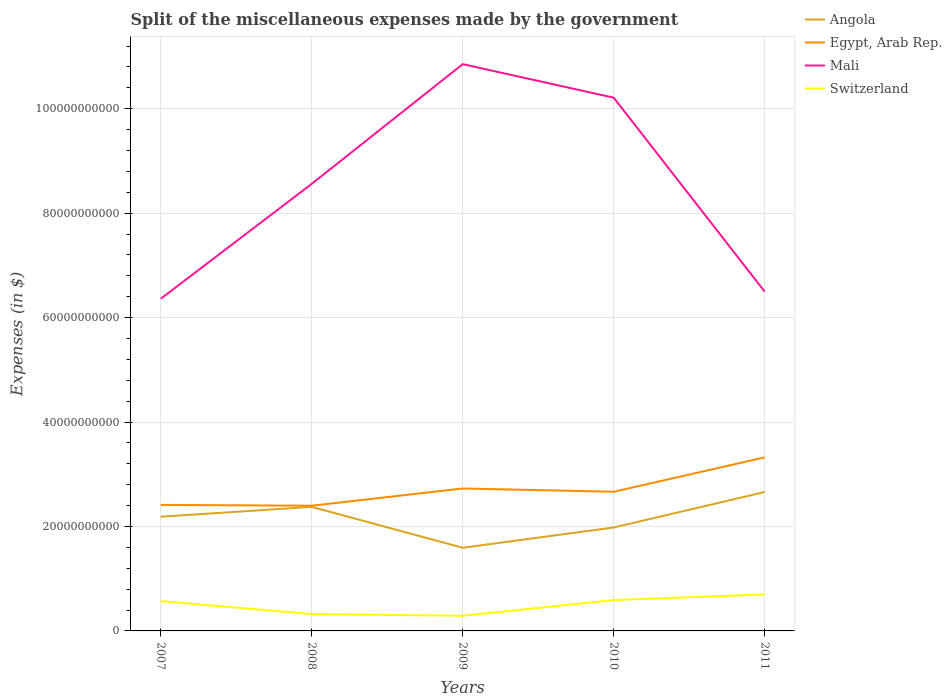How many different coloured lines are there?
Make the answer very short. 4. Does the line corresponding to Egypt, Arab Rep. intersect with the line corresponding to Angola?
Ensure brevity in your answer.  No. Across all years, what is the maximum miscellaneous expenses made by the government in Switzerland?
Provide a short and direct response. 2.91e+09. In which year was the miscellaneous expenses made by the government in Switzerland maximum?
Keep it short and to the point. 2009. What is the total miscellaneous expenses made by the government in Angola in the graph?
Offer a terse response. -6.79e+09. What is the difference between the highest and the second highest miscellaneous expenses made by the government in Angola?
Give a very brief answer. 1.07e+1. How many years are there in the graph?
Ensure brevity in your answer.  5. Where does the legend appear in the graph?
Offer a very short reply. Top right. How are the legend labels stacked?
Give a very brief answer. Vertical. What is the title of the graph?
Your answer should be very brief. Split of the miscellaneous expenses made by the government. Does "Indonesia" appear as one of the legend labels in the graph?
Your answer should be very brief. No. What is the label or title of the Y-axis?
Your answer should be compact. Expenses (in $). What is the Expenses (in $) in Angola in 2007?
Offer a terse response. 2.19e+1. What is the Expenses (in $) in Egypt, Arab Rep. in 2007?
Give a very brief answer. 2.41e+1. What is the Expenses (in $) of Mali in 2007?
Make the answer very short. 6.36e+1. What is the Expenses (in $) of Switzerland in 2007?
Provide a succinct answer. 5.72e+09. What is the Expenses (in $) of Angola in 2008?
Make the answer very short. 2.38e+1. What is the Expenses (in $) of Egypt, Arab Rep. in 2008?
Provide a short and direct response. 2.40e+1. What is the Expenses (in $) in Mali in 2008?
Ensure brevity in your answer.  8.56e+1. What is the Expenses (in $) of Switzerland in 2008?
Offer a terse response. 3.22e+09. What is the Expenses (in $) of Angola in 2009?
Ensure brevity in your answer.  1.59e+1. What is the Expenses (in $) in Egypt, Arab Rep. in 2009?
Give a very brief answer. 2.73e+1. What is the Expenses (in $) of Mali in 2009?
Your answer should be compact. 1.09e+11. What is the Expenses (in $) of Switzerland in 2009?
Offer a very short reply. 2.91e+09. What is the Expenses (in $) of Angola in 2010?
Ensure brevity in your answer.  1.98e+1. What is the Expenses (in $) of Egypt, Arab Rep. in 2010?
Keep it short and to the point. 2.66e+1. What is the Expenses (in $) of Mali in 2010?
Offer a very short reply. 1.02e+11. What is the Expenses (in $) of Switzerland in 2010?
Provide a short and direct response. 5.91e+09. What is the Expenses (in $) in Angola in 2011?
Give a very brief answer. 2.66e+1. What is the Expenses (in $) in Egypt, Arab Rep. in 2011?
Keep it short and to the point. 3.32e+1. What is the Expenses (in $) of Mali in 2011?
Provide a short and direct response. 6.50e+1. What is the Expenses (in $) in Switzerland in 2011?
Provide a short and direct response. 6.99e+09. Across all years, what is the maximum Expenses (in $) of Angola?
Make the answer very short. 2.66e+1. Across all years, what is the maximum Expenses (in $) in Egypt, Arab Rep.?
Give a very brief answer. 3.32e+1. Across all years, what is the maximum Expenses (in $) in Mali?
Make the answer very short. 1.09e+11. Across all years, what is the maximum Expenses (in $) in Switzerland?
Provide a succinct answer. 6.99e+09. Across all years, what is the minimum Expenses (in $) in Angola?
Your answer should be compact. 1.59e+1. Across all years, what is the minimum Expenses (in $) of Egypt, Arab Rep.?
Give a very brief answer. 2.40e+1. Across all years, what is the minimum Expenses (in $) in Mali?
Provide a succinct answer. 6.36e+1. Across all years, what is the minimum Expenses (in $) in Switzerland?
Keep it short and to the point. 2.91e+09. What is the total Expenses (in $) in Angola in the graph?
Offer a terse response. 1.08e+11. What is the total Expenses (in $) of Egypt, Arab Rep. in the graph?
Provide a short and direct response. 1.35e+11. What is the total Expenses (in $) of Mali in the graph?
Provide a short and direct response. 4.25e+11. What is the total Expenses (in $) of Switzerland in the graph?
Make the answer very short. 2.47e+1. What is the difference between the Expenses (in $) in Angola in 2007 and that in 2008?
Your answer should be very brief. -1.88e+09. What is the difference between the Expenses (in $) in Egypt, Arab Rep. in 2007 and that in 2008?
Offer a very short reply. 1.59e+08. What is the difference between the Expenses (in $) of Mali in 2007 and that in 2008?
Offer a very short reply. -2.20e+1. What is the difference between the Expenses (in $) in Switzerland in 2007 and that in 2008?
Offer a terse response. 2.49e+09. What is the difference between the Expenses (in $) in Angola in 2007 and that in 2009?
Give a very brief answer. 5.95e+09. What is the difference between the Expenses (in $) in Egypt, Arab Rep. in 2007 and that in 2009?
Make the answer very short. -3.14e+09. What is the difference between the Expenses (in $) in Mali in 2007 and that in 2009?
Make the answer very short. -4.49e+1. What is the difference between the Expenses (in $) in Switzerland in 2007 and that in 2009?
Provide a succinct answer. 2.81e+09. What is the difference between the Expenses (in $) of Angola in 2007 and that in 2010?
Give a very brief answer. 2.07e+09. What is the difference between the Expenses (in $) in Egypt, Arab Rep. in 2007 and that in 2010?
Your response must be concise. -2.52e+09. What is the difference between the Expenses (in $) of Mali in 2007 and that in 2010?
Your answer should be compact. -3.85e+1. What is the difference between the Expenses (in $) of Switzerland in 2007 and that in 2010?
Provide a succinct answer. -1.89e+08. What is the difference between the Expenses (in $) of Angola in 2007 and that in 2011?
Keep it short and to the point. -4.73e+09. What is the difference between the Expenses (in $) of Egypt, Arab Rep. in 2007 and that in 2011?
Offer a terse response. -9.10e+09. What is the difference between the Expenses (in $) in Mali in 2007 and that in 2011?
Give a very brief answer. -1.37e+09. What is the difference between the Expenses (in $) in Switzerland in 2007 and that in 2011?
Keep it short and to the point. -1.28e+09. What is the difference between the Expenses (in $) in Angola in 2008 and that in 2009?
Ensure brevity in your answer.  7.83e+09. What is the difference between the Expenses (in $) in Egypt, Arab Rep. in 2008 and that in 2009?
Ensure brevity in your answer.  -3.30e+09. What is the difference between the Expenses (in $) in Mali in 2008 and that in 2009?
Provide a short and direct response. -2.29e+1. What is the difference between the Expenses (in $) in Switzerland in 2008 and that in 2009?
Keep it short and to the point. 3.19e+08. What is the difference between the Expenses (in $) in Angola in 2008 and that in 2010?
Your answer should be very brief. 3.95e+09. What is the difference between the Expenses (in $) in Egypt, Arab Rep. in 2008 and that in 2010?
Your answer should be compact. -2.67e+09. What is the difference between the Expenses (in $) of Mali in 2008 and that in 2010?
Your answer should be very brief. -1.65e+1. What is the difference between the Expenses (in $) of Switzerland in 2008 and that in 2010?
Keep it short and to the point. -2.68e+09. What is the difference between the Expenses (in $) of Angola in 2008 and that in 2011?
Make the answer very short. -2.84e+09. What is the difference between the Expenses (in $) in Egypt, Arab Rep. in 2008 and that in 2011?
Give a very brief answer. -9.26e+09. What is the difference between the Expenses (in $) of Mali in 2008 and that in 2011?
Ensure brevity in your answer.  2.06e+1. What is the difference between the Expenses (in $) of Switzerland in 2008 and that in 2011?
Keep it short and to the point. -3.77e+09. What is the difference between the Expenses (in $) in Angola in 2009 and that in 2010?
Provide a short and direct response. -3.88e+09. What is the difference between the Expenses (in $) of Egypt, Arab Rep. in 2009 and that in 2010?
Give a very brief answer. 6.29e+08. What is the difference between the Expenses (in $) of Mali in 2009 and that in 2010?
Offer a terse response. 6.42e+09. What is the difference between the Expenses (in $) in Switzerland in 2009 and that in 2010?
Offer a very short reply. -3.00e+09. What is the difference between the Expenses (in $) of Angola in 2009 and that in 2011?
Provide a short and direct response. -1.07e+1. What is the difference between the Expenses (in $) of Egypt, Arab Rep. in 2009 and that in 2011?
Your answer should be very brief. -5.96e+09. What is the difference between the Expenses (in $) of Mali in 2009 and that in 2011?
Offer a very short reply. 4.36e+1. What is the difference between the Expenses (in $) of Switzerland in 2009 and that in 2011?
Your answer should be very brief. -4.09e+09. What is the difference between the Expenses (in $) of Angola in 2010 and that in 2011?
Keep it short and to the point. -6.79e+09. What is the difference between the Expenses (in $) of Egypt, Arab Rep. in 2010 and that in 2011?
Provide a succinct answer. -6.59e+09. What is the difference between the Expenses (in $) in Mali in 2010 and that in 2011?
Provide a short and direct response. 3.71e+1. What is the difference between the Expenses (in $) of Switzerland in 2010 and that in 2011?
Your response must be concise. -1.09e+09. What is the difference between the Expenses (in $) in Angola in 2007 and the Expenses (in $) in Egypt, Arab Rep. in 2008?
Offer a terse response. -2.10e+09. What is the difference between the Expenses (in $) of Angola in 2007 and the Expenses (in $) of Mali in 2008?
Make the answer very short. -6.37e+1. What is the difference between the Expenses (in $) of Angola in 2007 and the Expenses (in $) of Switzerland in 2008?
Keep it short and to the point. 1.86e+1. What is the difference between the Expenses (in $) of Egypt, Arab Rep. in 2007 and the Expenses (in $) of Mali in 2008?
Ensure brevity in your answer.  -6.15e+1. What is the difference between the Expenses (in $) of Egypt, Arab Rep. in 2007 and the Expenses (in $) of Switzerland in 2008?
Ensure brevity in your answer.  2.09e+1. What is the difference between the Expenses (in $) of Mali in 2007 and the Expenses (in $) of Switzerland in 2008?
Keep it short and to the point. 6.04e+1. What is the difference between the Expenses (in $) in Angola in 2007 and the Expenses (in $) in Egypt, Arab Rep. in 2009?
Offer a terse response. -5.41e+09. What is the difference between the Expenses (in $) of Angola in 2007 and the Expenses (in $) of Mali in 2009?
Make the answer very short. -8.67e+1. What is the difference between the Expenses (in $) in Angola in 2007 and the Expenses (in $) in Switzerland in 2009?
Your response must be concise. 1.90e+1. What is the difference between the Expenses (in $) of Egypt, Arab Rep. in 2007 and the Expenses (in $) of Mali in 2009?
Keep it short and to the point. -8.44e+1. What is the difference between the Expenses (in $) of Egypt, Arab Rep. in 2007 and the Expenses (in $) of Switzerland in 2009?
Your answer should be compact. 2.12e+1. What is the difference between the Expenses (in $) in Mali in 2007 and the Expenses (in $) in Switzerland in 2009?
Keep it short and to the point. 6.07e+1. What is the difference between the Expenses (in $) in Angola in 2007 and the Expenses (in $) in Egypt, Arab Rep. in 2010?
Keep it short and to the point. -4.78e+09. What is the difference between the Expenses (in $) in Angola in 2007 and the Expenses (in $) in Mali in 2010?
Make the answer very short. -8.02e+1. What is the difference between the Expenses (in $) in Angola in 2007 and the Expenses (in $) in Switzerland in 2010?
Offer a very short reply. 1.60e+1. What is the difference between the Expenses (in $) of Egypt, Arab Rep. in 2007 and the Expenses (in $) of Mali in 2010?
Keep it short and to the point. -7.80e+1. What is the difference between the Expenses (in $) in Egypt, Arab Rep. in 2007 and the Expenses (in $) in Switzerland in 2010?
Give a very brief answer. 1.82e+1. What is the difference between the Expenses (in $) in Mali in 2007 and the Expenses (in $) in Switzerland in 2010?
Make the answer very short. 5.77e+1. What is the difference between the Expenses (in $) of Angola in 2007 and the Expenses (in $) of Egypt, Arab Rep. in 2011?
Your answer should be very brief. -1.14e+1. What is the difference between the Expenses (in $) of Angola in 2007 and the Expenses (in $) of Mali in 2011?
Provide a succinct answer. -4.31e+1. What is the difference between the Expenses (in $) in Angola in 2007 and the Expenses (in $) in Switzerland in 2011?
Provide a short and direct response. 1.49e+1. What is the difference between the Expenses (in $) in Egypt, Arab Rep. in 2007 and the Expenses (in $) in Mali in 2011?
Your response must be concise. -4.08e+1. What is the difference between the Expenses (in $) in Egypt, Arab Rep. in 2007 and the Expenses (in $) in Switzerland in 2011?
Your answer should be compact. 1.71e+1. What is the difference between the Expenses (in $) in Mali in 2007 and the Expenses (in $) in Switzerland in 2011?
Your answer should be very brief. 5.66e+1. What is the difference between the Expenses (in $) in Angola in 2008 and the Expenses (in $) in Egypt, Arab Rep. in 2009?
Offer a terse response. -3.52e+09. What is the difference between the Expenses (in $) in Angola in 2008 and the Expenses (in $) in Mali in 2009?
Make the answer very short. -8.48e+1. What is the difference between the Expenses (in $) of Angola in 2008 and the Expenses (in $) of Switzerland in 2009?
Offer a very short reply. 2.08e+1. What is the difference between the Expenses (in $) in Egypt, Arab Rep. in 2008 and the Expenses (in $) in Mali in 2009?
Your response must be concise. -8.46e+1. What is the difference between the Expenses (in $) of Egypt, Arab Rep. in 2008 and the Expenses (in $) of Switzerland in 2009?
Your answer should be compact. 2.11e+1. What is the difference between the Expenses (in $) in Mali in 2008 and the Expenses (in $) in Switzerland in 2009?
Make the answer very short. 8.27e+1. What is the difference between the Expenses (in $) of Angola in 2008 and the Expenses (in $) of Egypt, Arab Rep. in 2010?
Offer a very short reply. -2.89e+09. What is the difference between the Expenses (in $) in Angola in 2008 and the Expenses (in $) in Mali in 2010?
Offer a very short reply. -7.84e+1. What is the difference between the Expenses (in $) of Angola in 2008 and the Expenses (in $) of Switzerland in 2010?
Make the answer very short. 1.78e+1. What is the difference between the Expenses (in $) of Egypt, Arab Rep. in 2008 and the Expenses (in $) of Mali in 2010?
Provide a short and direct response. -7.81e+1. What is the difference between the Expenses (in $) of Egypt, Arab Rep. in 2008 and the Expenses (in $) of Switzerland in 2010?
Offer a terse response. 1.81e+1. What is the difference between the Expenses (in $) in Mali in 2008 and the Expenses (in $) in Switzerland in 2010?
Your answer should be very brief. 7.97e+1. What is the difference between the Expenses (in $) of Angola in 2008 and the Expenses (in $) of Egypt, Arab Rep. in 2011?
Provide a succinct answer. -9.48e+09. What is the difference between the Expenses (in $) of Angola in 2008 and the Expenses (in $) of Mali in 2011?
Keep it short and to the point. -4.12e+1. What is the difference between the Expenses (in $) of Angola in 2008 and the Expenses (in $) of Switzerland in 2011?
Your answer should be very brief. 1.68e+1. What is the difference between the Expenses (in $) in Egypt, Arab Rep. in 2008 and the Expenses (in $) in Mali in 2011?
Offer a very short reply. -4.10e+1. What is the difference between the Expenses (in $) of Egypt, Arab Rep. in 2008 and the Expenses (in $) of Switzerland in 2011?
Give a very brief answer. 1.70e+1. What is the difference between the Expenses (in $) of Mali in 2008 and the Expenses (in $) of Switzerland in 2011?
Keep it short and to the point. 7.86e+1. What is the difference between the Expenses (in $) in Angola in 2009 and the Expenses (in $) in Egypt, Arab Rep. in 2010?
Ensure brevity in your answer.  -1.07e+1. What is the difference between the Expenses (in $) of Angola in 2009 and the Expenses (in $) of Mali in 2010?
Give a very brief answer. -8.62e+1. What is the difference between the Expenses (in $) in Angola in 2009 and the Expenses (in $) in Switzerland in 2010?
Make the answer very short. 1.00e+1. What is the difference between the Expenses (in $) in Egypt, Arab Rep. in 2009 and the Expenses (in $) in Mali in 2010?
Make the answer very short. -7.48e+1. What is the difference between the Expenses (in $) of Egypt, Arab Rep. in 2009 and the Expenses (in $) of Switzerland in 2010?
Provide a short and direct response. 2.14e+1. What is the difference between the Expenses (in $) of Mali in 2009 and the Expenses (in $) of Switzerland in 2010?
Offer a terse response. 1.03e+11. What is the difference between the Expenses (in $) of Angola in 2009 and the Expenses (in $) of Egypt, Arab Rep. in 2011?
Your answer should be very brief. -1.73e+1. What is the difference between the Expenses (in $) of Angola in 2009 and the Expenses (in $) of Mali in 2011?
Make the answer very short. -4.90e+1. What is the difference between the Expenses (in $) in Angola in 2009 and the Expenses (in $) in Switzerland in 2011?
Keep it short and to the point. 8.93e+09. What is the difference between the Expenses (in $) of Egypt, Arab Rep. in 2009 and the Expenses (in $) of Mali in 2011?
Your answer should be very brief. -3.77e+1. What is the difference between the Expenses (in $) of Egypt, Arab Rep. in 2009 and the Expenses (in $) of Switzerland in 2011?
Make the answer very short. 2.03e+1. What is the difference between the Expenses (in $) in Mali in 2009 and the Expenses (in $) in Switzerland in 2011?
Offer a very short reply. 1.02e+11. What is the difference between the Expenses (in $) of Angola in 2010 and the Expenses (in $) of Egypt, Arab Rep. in 2011?
Provide a succinct answer. -1.34e+1. What is the difference between the Expenses (in $) of Angola in 2010 and the Expenses (in $) of Mali in 2011?
Keep it short and to the point. -4.52e+1. What is the difference between the Expenses (in $) of Angola in 2010 and the Expenses (in $) of Switzerland in 2011?
Provide a short and direct response. 1.28e+1. What is the difference between the Expenses (in $) of Egypt, Arab Rep. in 2010 and the Expenses (in $) of Mali in 2011?
Provide a succinct answer. -3.83e+1. What is the difference between the Expenses (in $) of Egypt, Arab Rep. in 2010 and the Expenses (in $) of Switzerland in 2011?
Make the answer very short. 1.97e+1. What is the difference between the Expenses (in $) in Mali in 2010 and the Expenses (in $) in Switzerland in 2011?
Provide a succinct answer. 9.51e+1. What is the average Expenses (in $) of Angola per year?
Make the answer very short. 2.16e+1. What is the average Expenses (in $) of Egypt, Arab Rep. per year?
Provide a succinct answer. 2.71e+1. What is the average Expenses (in $) in Mali per year?
Give a very brief answer. 8.50e+1. What is the average Expenses (in $) of Switzerland per year?
Your answer should be compact. 4.95e+09. In the year 2007, what is the difference between the Expenses (in $) of Angola and Expenses (in $) of Egypt, Arab Rep.?
Make the answer very short. -2.26e+09. In the year 2007, what is the difference between the Expenses (in $) in Angola and Expenses (in $) in Mali?
Offer a terse response. -4.17e+1. In the year 2007, what is the difference between the Expenses (in $) in Angola and Expenses (in $) in Switzerland?
Your response must be concise. 1.62e+1. In the year 2007, what is the difference between the Expenses (in $) of Egypt, Arab Rep. and Expenses (in $) of Mali?
Give a very brief answer. -3.95e+1. In the year 2007, what is the difference between the Expenses (in $) of Egypt, Arab Rep. and Expenses (in $) of Switzerland?
Give a very brief answer. 1.84e+1. In the year 2007, what is the difference between the Expenses (in $) in Mali and Expenses (in $) in Switzerland?
Give a very brief answer. 5.79e+1. In the year 2008, what is the difference between the Expenses (in $) of Angola and Expenses (in $) of Egypt, Arab Rep.?
Make the answer very short. -2.19e+08. In the year 2008, what is the difference between the Expenses (in $) in Angola and Expenses (in $) in Mali?
Provide a succinct answer. -6.19e+1. In the year 2008, what is the difference between the Expenses (in $) in Angola and Expenses (in $) in Switzerland?
Your answer should be compact. 2.05e+1. In the year 2008, what is the difference between the Expenses (in $) in Egypt, Arab Rep. and Expenses (in $) in Mali?
Keep it short and to the point. -6.16e+1. In the year 2008, what is the difference between the Expenses (in $) of Egypt, Arab Rep. and Expenses (in $) of Switzerland?
Ensure brevity in your answer.  2.07e+1. In the year 2008, what is the difference between the Expenses (in $) of Mali and Expenses (in $) of Switzerland?
Give a very brief answer. 8.24e+1. In the year 2009, what is the difference between the Expenses (in $) of Angola and Expenses (in $) of Egypt, Arab Rep.?
Provide a succinct answer. -1.14e+1. In the year 2009, what is the difference between the Expenses (in $) of Angola and Expenses (in $) of Mali?
Keep it short and to the point. -9.26e+1. In the year 2009, what is the difference between the Expenses (in $) of Angola and Expenses (in $) of Switzerland?
Provide a short and direct response. 1.30e+1. In the year 2009, what is the difference between the Expenses (in $) of Egypt, Arab Rep. and Expenses (in $) of Mali?
Make the answer very short. -8.13e+1. In the year 2009, what is the difference between the Expenses (in $) in Egypt, Arab Rep. and Expenses (in $) in Switzerland?
Your answer should be very brief. 2.44e+1. In the year 2009, what is the difference between the Expenses (in $) in Mali and Expenses (in $) in Switzerland?
Offer a terse response. 1.06e+11. In the year 2010, what is the difference between the Expenses (in $) in Angola and Expenses (in $) in Egypt, Arab Rep.?
Keep it short and to the point. -6.84e+09. In the year 2010, what is the difference between the Expenses (in $) in Angola and Expenses (in $) in Mali?
Keep it short and to the point. -8.23e+1. In the year 2010, what is the difference between the Expenses (in $) of Angola and Expenses (in $) of Switzerland?
Provide a succinct answer. 1.39e+1. In the year 2010, what is the difference between the Expenses (in $) of Egypt, Arab Rep. and Expenses (in $) of Mali?
Provide a succinct answer. -7.55e+1. In the year 2010, what is the difference between the Expenses (in $) in Egypt, Arab Rep. and Expenses (in $) in Switzerland?
Make the answer very short. 2.07e+1. In the year 2010, what is the difference between the Expenses (in $) of Mali and Expenses (in $) of Switzerland?
Give a very brief answer. 9.62e+1. In the year 2011, what is the difference between the Expenses (in $) in Angola and Expenses (in $) in Egypt, Arab Rep.?
Offer a very short reply. -6.64e+09. In the year 2011, what is the difference between the Expenses (in $) in Angola and Expenses (in $) in Mali?
Provide a succinct answer. -3.84e+1. In the year 2011, what is the difference between the Expenses (in $) of Angola and Expenses (in $) of Switzerland?
Keep it short and to the point. 1.96e+1. In the year 2011, what is the difference between the Expenses (in $) in Egypt, Arab Rep. and Expenses (in $) in Mali?
Your response must be concise. -3.17e+1. In the year 2011, what is the difference between the Expenses (in $) of Egypt, Arab Rep. and Expenses (in $) of Switzerland?
Your answer should be compact. 2.62e+1. In the year 2011, what is the difference between the Expenses (in $) of Mali and Expenses (in $) of Switzerland?
Ensure brevity in your answer.  5.80e+1. What is the ratio of the Expenses (in $) in Angola in 2007 to that in 2008?
Make the answer very short. 0.92. What is the ratio of the Expenses (in $) in Egypt, Arab Rep. in 2007 to that in 2008?
Offer a very short reply. 1.01. What is the ratio of the Expenses (in $) in Mali in 2007 to that in 2008?
Give a very brief answer. 0.74. What is the ratio of the Expenses (in $) in Switzerland in 2007 to that in 2008?
Ensure brevity in your answer.  1.77. What is the ratio of the Expenses (in $) of Angola in 2007 to that in 2009?
Offer a very short reply. 1.37. What is the ratio of the Expenses (in $) of Egypt, Arab Rep. in 2007 to that in 2009?
Ensure brevity in your answer.  0.88. What is the ratio of the Expenses (in $) of Mali in 2007 to that in 2009?
Offer a very short reply. 0.59. What is the ratio of the Expenses (in $) in Switzerland in 2007 to that in 2009?
Your answer should be compact. 1.97. What is the ratio of the Expenses (in $) of Angola in 2007 to that in 2010?
Offer a very short reply. 1.1. What is the ratio of the Expenses (in $) in Egypt, Arab Rep. in 2007 to that in 2010?
Ensure brevity in your answer.  0.91. What is the ratio of the Expenses (in $) of Mali in 2007 to that in 2010?
Keep it short and to the point. 0.62. What is the ratio of the Expenses (in $) in Angola in 2007 to that in 2011?
Your answer should be compact. 0.82. What is the ratio of the Expenses (in $) of Egypt, Arab Rep. in 2007 to that in 2011?
Offer a very short reply. 0.73. What is the ratio of the Expenses (in $) in Mali in 2007 to that in 2011?
Your response must be concise. 0.98. What is the ratio of the Expenses (in $) in Switzerland in 2007 to that in 2011?
Your answer should be compact. 0.82. What is the ratio of the Expenses (in $) in Angola in 2008 to that in 2009?
Make the answer very short. 1.49. What is the ratio of the Expenses (in $) in Egypt, Arab Rep. in 2008 to that in 2009?
Your answer should be very brief. 0.88. What is the ratio of the Expenses (in $) in Mali in 2008 to that in 2009?
Offer a terse response. 0.79. What is the ratio of the Expenses (in $) of Switzerland in 2008 to that in 2009?
Your answer should be compact. 1.11. What is the ratio of the Expenses (in $) in Angola in 2008 to that in 2010?
Keep it short and to the point. 1.2. What is the ratio of the Expenses (in $) in Egypt, Arab Rep. in 2008 to that in 2010?
Offer a very short reply. 0.9. What is the ratio of the Expenses (in $) in Mali in 2008 to that in 2010?
Give a very brief answer. 0.84. What is the ratio of the Expenses (in $) of Switzerland in 2008 to that in 2010?
Keep it short and to the point. 0.55. What is the ratio of the Expenses (in $) in Angola in 2008 to that in 2011?
Keep it short and to the point. 0.89. What is the ratio of the Expenses (in $) of Egypt, Arab Rep. in 2008 to that in 2011?
Offer a very short reply. 0.72. What is the ratio of the Expenses (in $) of Mali in 2008 to that in 2011?
Offer a very short reply. 1.32. What is the ratio of the Expenses (in $) of Switzerland in 2008 to that in 2011?
Offer a very short reply. 0.46. What is the ratio of the Expenses (in $) of Angola in 2009 to that in 2010?
Your answer should be compact. 0.8. What is the ratio of the Expenses (in $) of Egypt, Arab Rep. in 2009 to that in 2010?
Your answer should be very brief. 1.02. What is the ratio of the Expenses (in $) of Mali in 2009 to that in 2010?
Offer a very short reply. 1.06. What is the ratio of the Expenses (in $) of Switzerland in 2009 to that in 2010?
Give a very brief answer. 0.49. What is the ratio of the Expenses (in $) in Angola in 2009 to that in 2011?
Provide a short and direct response. 0.6. What is the ratio of the Expenses (in $) of Egypt, Arab Rep. in 2009 to that in 2011?
Provide a succinct answer. 0.82. What is the ratio of the Expenses (in $) of Mali in 2009 to that in 2011?
Your response must be concise. 1.67. What is the ratio of the Expenses (in $) in Switzerland in 2009 to that in 2011?
Your answer should be compact. 0.42. What is the ratio of the Expenses (in $) in Angola in 2010 to that in 2011?
Offer a very short reply. 0.74. What is the ratio of the Expenses (in $) of Egypt, Arab Rep. in 2010 to that in 2011?
Make the answer very short. 0.8. What is the ratio of the Expenses (in $) of Mali in 2010 to that in 2011?
Ensure brevity in your answer.  1.57. What is the ratio of the Expenses (in $) of Switzerland in 2010 to that in 2011?
Offer a very short reply. 0.84. What is the difference between the highest and the second highest Expenses (in $) of Angola?
Make the answer very short. 2.84e+09. What is the difference between the highest and the second highest Expenses (in $) in Egypt, Arab Rep.?
Ensure brevity in your answer.  5.96e+09. What is the difference between the highest and the second highest Expenses (in $) in Mali?
Your response must be concise. 6.42e+09. What is the difference between the highest and the second highest Expenses (in $) of Switzerland?
Your response must be concise. 1.09e+09. What is the difference between the highest and the lowest Expenses (in $) in Angola?
Provide a succinct answer. 1.07e+1. What is the difference between the highest and the lowest Expenses (in $) in Egypt, Arab Rep.?
Provide a succinct answer. 9.26e+09. What is the difference between the highest and the lowest Expenses (in $) of Mali?
Your answer should be very brief. 4.49e+1. What is the difference between the highest and the lowest Expenses (in $) in Switzerland?
Your response must be concise. 4.09e+09. 